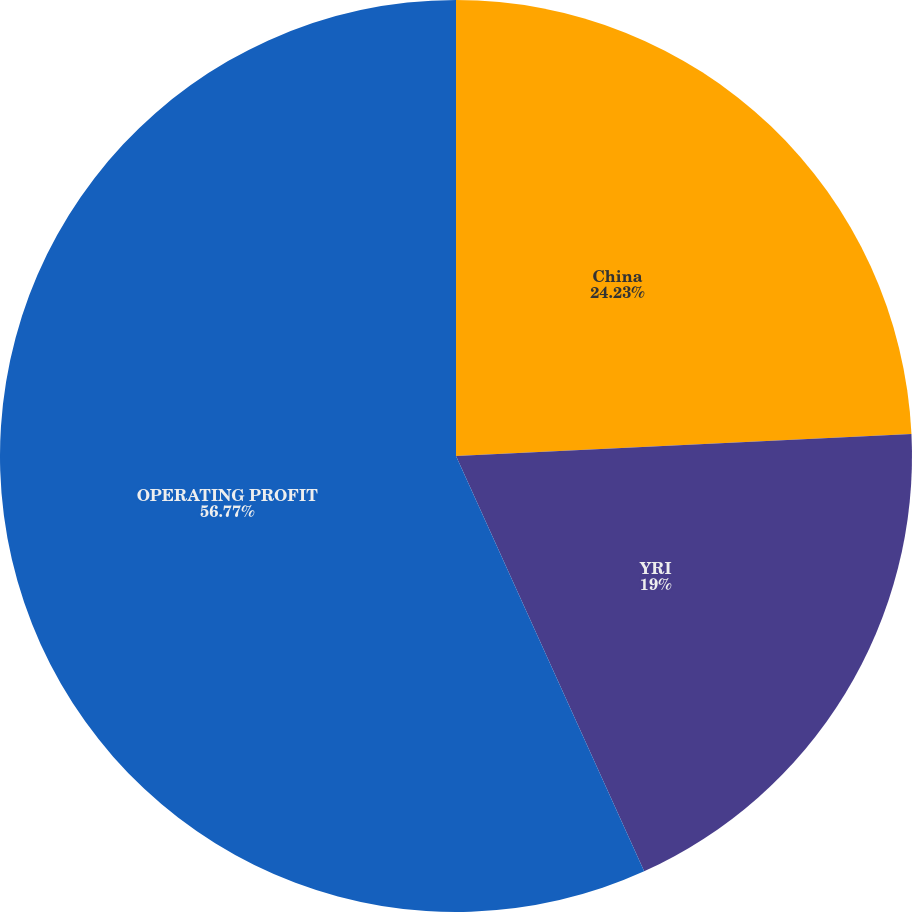Convert chart to OTSL. <chart><loc_0><loc_0><loc_500><loc_500><pie_chart><fcel>China<fcel>YRI<fcel>OPERATING PROFIT<nl><fcel>24.23%<fcel>19.0%<fcel>56.77%<nl></chart> 